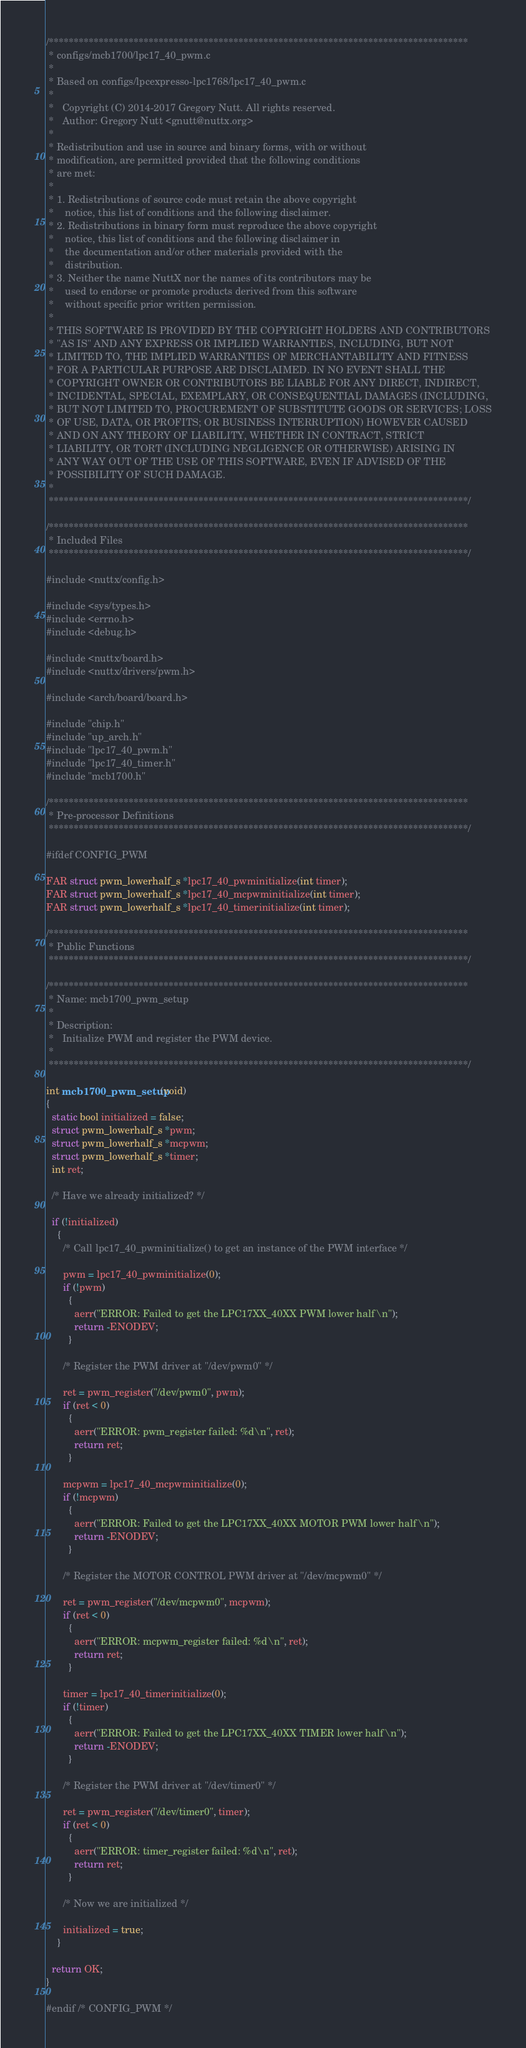Convert code to text. <code><loc_0><loc_0><loc_500><loc_500><_C_>/************************************************************************************
 * configs/mcb1700/lpc17_40_pwm.c
 *
 * Based on configs/lpcexpresso-lpc1768/lpc17_40_pwm.c
 *
 *   Copyright (C) 2014-2017 Gregory Nutt. All rights reserved.
 *   Author: Gregory Nutt <gnutt@nuttx.org>
 *
 * Redistribution and use in source and binary forms, with or without
 * modification, are permitted provided that the following conditions
 * are met:
 *
 * 1. Redistributions of source code must retain the above copyright
 *    notice, this list of conditions and the following disclaimer.
 * 2. Redistributions in binary form must reproduce the above copyright
 *    notice, this list of conditions and the following disclaimer in
 *    the documentation and/or other materials provided with the
 *    distribution.
 * 3. Neither the name NuttX nor the names of its contributors may be
 *    used to endorse or promote products derived from this software
 *    without specific prior written permission.
 *
 * THIS SOFTWARE IS PROVIDED BY THE COPYRIGHT HOLDERS AND CONTRIBUTORS
 * "AS IS" AND ANY EXPRESS OR IMPLIED WARRANTIES, INCLUDING, BUT NOT
 * LIMITED TO, THE IMPLIED WARRANTIES OF MERCHANTABILITY AND FITNESS
 * FOR A PARTICULAR PURPOSE ARE DISCLAIMED. IN NO EVENT SHALL THE
 * COPYRIGHT OWNER OR CONTRIBUTORS BE LIABLE FOR ANY DIRECT, INDIRECT,
 * INCIDENTAL, SPECIAL, EXEMPLARY, OR CONSEQUENTIAL DAMAGES (INCLUDING,
 * BUT NOT LIMITED TO, PROCUREMENT OF SUBSTITUTE GOODS OR SERVICES; LOSS
 * OF USE, DATA, OR PROFITS; OR BUSINESS INTERRUPTION) HOWEVER CAUSED
 * AND ON ANY THEORY OF LIABILITY, WHETHER IN CONTRACT, STRICT
 * LIABILITY, OR TORT (INCLUDING NEGLIGENCE OR OTHERWISE) ARISING IN
 * ANY WAY OUT OF THE USE OF THIS SOFTWARE, EVEN IF ADVISED OF THE
 * POSSIBILITY OF SUCH DAMAGE.
 *
 ************************************************************************************/

/************************************************************************************
 * Included Files
 ************************************************************************************/

#include <nuttx/config.h>

#include <sys/types.h>
#include <errno.h>
#include <debug.h>

#include <nuttx/board.h>
#include <nuttx/drivers/pwm.h>

#include <arch/board/board.h>

#include "chip.h"
#include "up_arch.h"
#include "lpc17_40_pwm.h"
#include "lpc17_40_timer.h"
#include "mcb1700.h"

/************************************************************************************
 * Pre-processor Definitions
 ************************************************************************************/

#ifdef CONFIG_PWM

FAR struct pwm_lowerhalf_s *lpc17_40_pwminitialize(int timer);
FAR struct pwm_lowerhalf_s *lpc17_40_mcpwminitialize(int timer);
FAR struct pwm_lowerhalf_s *lpc17_40_timerinitialize(int timer);

/************************************************************************************
 * Public Functions
 ************************************************************************************/

/************************************************************************************
 * Name: mcb1700_pwm_setup
 *
 * Description:
 *   Initialize PWM and register the PWM device.
 *
 ************************************************************************************/

int mcb1700_pwm_setup(void)
{
  static bool initialized = false;
  struct pwm_lowerhalf_s *pwm;
  struct pwm_lowerhalf_s *mcpwm;
  struct pwm_lowerhalf_s *timer;
  int ret;

  /* Have we already initialized? */

  if (!initialized)
    {
      /* Call lpc17_40_pwminitialize() to get an instance of the PWM interface */

      pwm = lpc17_40_pwminitialize(0);
      if (!pwm)
        {
          aerr("ERROR: Failed to get the LPC17XX_40XX PWM lower half\n");
          return -ENODEV;
        }

      /* Register the PWM driver at "/dev/pwm0" */

      ret = pwm_register("/dev/pwm0", pwm);
      if (ret < 0)
        {
          aerr("ERROR: pwm_register failed: %d\n", ret);
          return ret;
        }

      mcpwm = lpc17_40_mcpwminitialize(0);
      if (!mcpwm)
        {
          aerr("ERROR: Failed to get the LPC17XX_40XX MOTOR PWM lower half\n");
          return -ENODEV;
        }

      /* Register the MOTOR CONTROL PWM driver at "/dev/mcpwm0" */

      ret = pwm_register("/dev/mcpwm0", mcpwm);
      if (ret < 0)
        {
          aerr("ERROR: mcpwm_register failed: %d\n", ret);
          return ret;
        }

      timer = lpc17_40_timerinitialize(0);
      if (!timer)
        {
          aerr("ERROR: Failed to get the LPC17XX_40XX TIMER lower half\n");
          return -ENODEV;
        }

      /* Register the PWM driver at "/dev/timer0" */

      ret = pwm_register("/dev/timer0", timer);
      if (ret < 0)
        {
          aerr("ERROR: timer_register failed: %d\n", ret);
          return ret;
        }

      /* Now we are initialized */

      initialized = true;
    }

  return OK;
}

#endif /* CONFIG_PWM */
</code> 